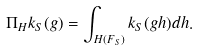Convert formula to latex. <formula><loc_0><loc_0><loc_500><loc_500>\Pi _ { H } k _ { S } ( g ) = \int _ { H ( F _ { S } ) } k _ { S } ( g h ) d h .</formula> 